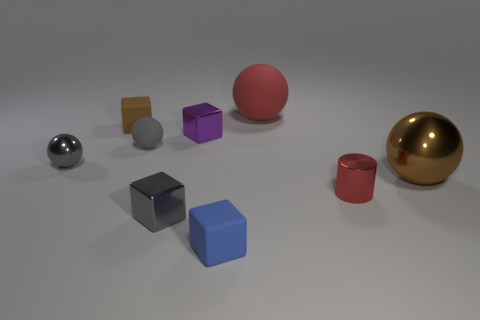Subtract 1 cubes. How many cubes are left? 3 Subtract all cylinders. How many objects are left? 8 Add 2 large gray rubber spheres. How many large gray rubber spheres exist? 2 Subtract 0 green cylinders. How many objects are left? 9 Subtract all small blue rubber blocks. Subtract all gray rubber things. How many objects are left? 7 Add 1 metal cubes. How many metal cubes are left? 3 